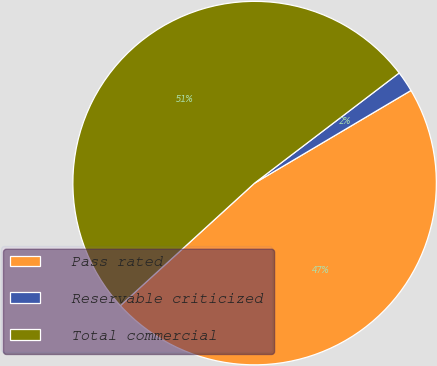Convert chart. <chart><loc_0><loc_0><loc_500><loc_500><pie_chart><fcel>Pass rated<fcel>Reservable criticized<fcel>Total commercial<nl><fcel>46.74%<fcel>1.85%<fcel>51.41%<nl></chart> 